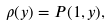<formula> <loc_0><loc_0><loc_500><loc_500>\rho ( y ) = P ( 1 , y ) ,</formula> 